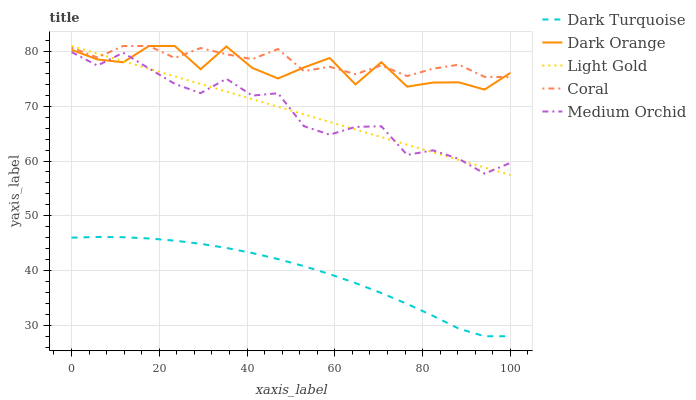Does Dark Turquoise have the minimum area under the curve?
Answer yes or no. Yes. Does Coral have the maximum area under the curve?
Answer yes or no. Yes. Does Medium Orchid have the minimum area under the curve?
Answer yes or no. No. Does Medium Orchid have the maximum area under the curve?
Answer yes or no. No. Is Light Gold the smoothest?
Answer yes or no. Yes. Is Dark Orange the roughest?
Answer yes or no. Yes. Is Coral the smoothest?
Answer yes or no. No. Is Coral the roughest?
Answer yes or no. No. Does Dark Turquoise have the lowest value?
Answer yes or no. Yes. Does Medium Orchid have the lowest value?
Answer yes or no. No. Does Dark Orange have the highest value?
Answer yes or no. Yes. Does Medium Orchid have the highest value?
Answer yes or no. No. Is Dark Turquoise less than Medium Orchid?
Answer yes or no. Yes. Is Light Gold greater than Dark Turquoise?
Answer yes or no. Yes. Does Dark Orange intersect Coral?
Answer yes or no. Yes. Is Dark Orange less than Coral?
Answer yes or no. No. Is Dark Orange greater than Coral?
Answer yes or no. No. Does Dark Turquoise intersect Medium Orchid?
Answer yes or no. No. 